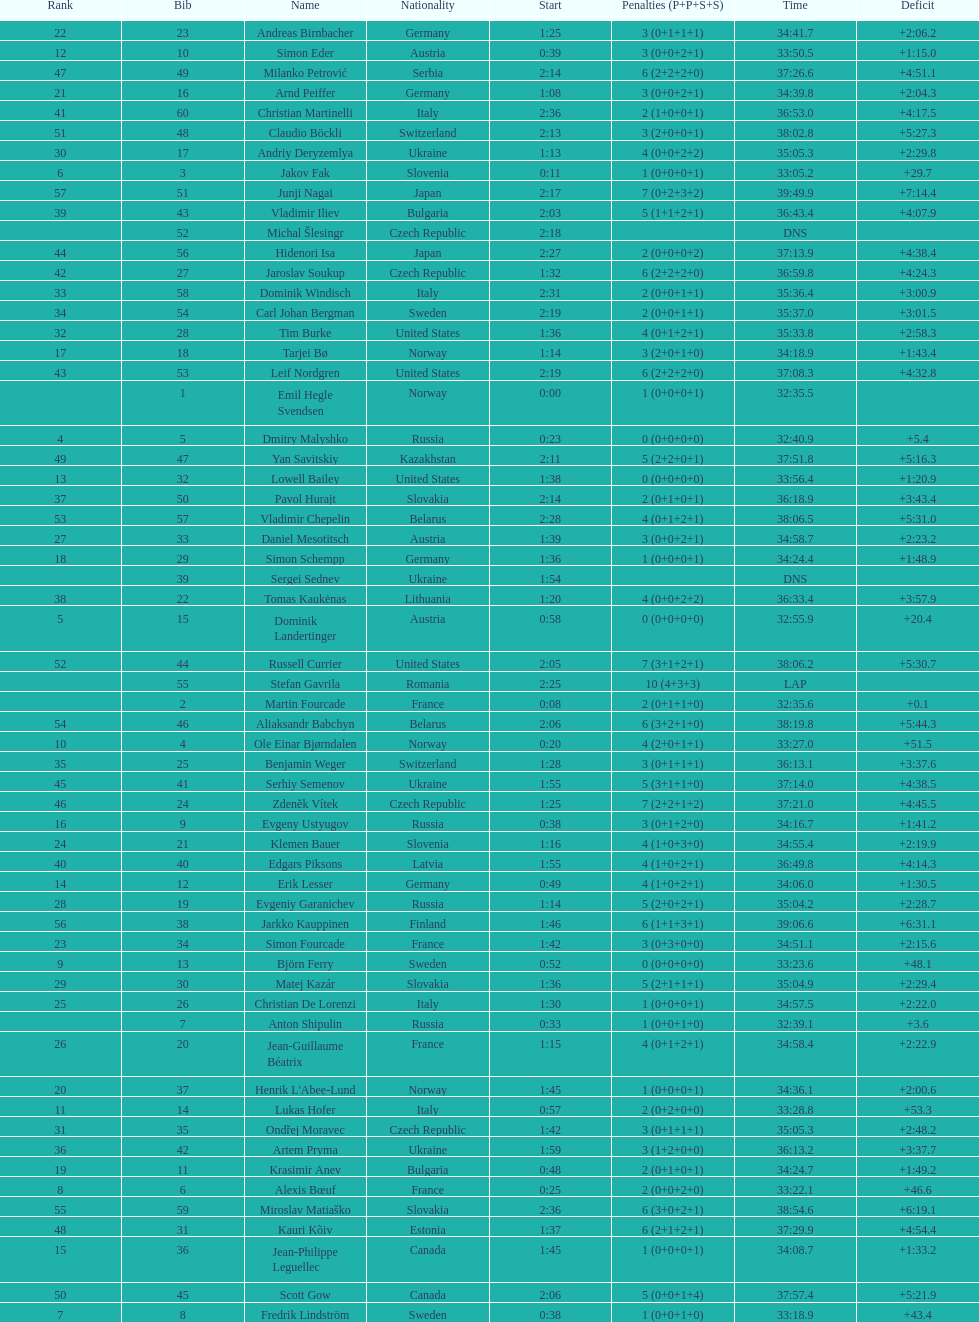What is the number of russian participants? 4. 